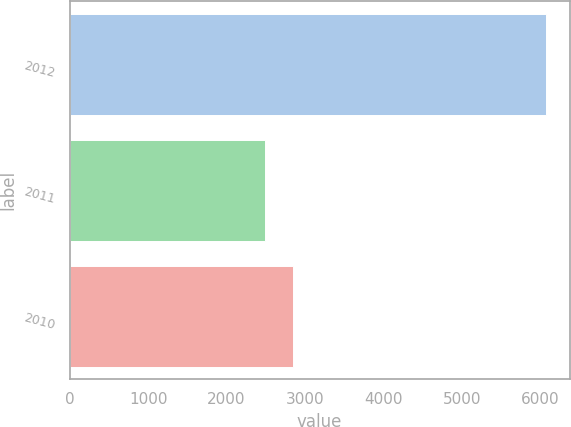Convert chart to OTSL. <chart><loc_0><loc_0><loc_500><loc_500><bar_chart><fcel>2012<fcel>2011<fcel>2010<nl><fcel>6072<fcel>2489<fcel>2847.3<nl></chart> 